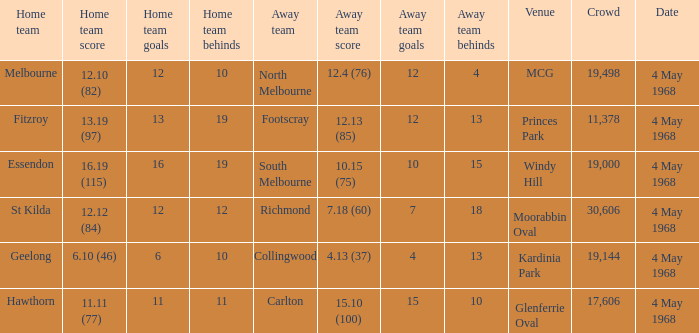How big was the crowd of the team that scored 4.13 (37)? 19144.0. 